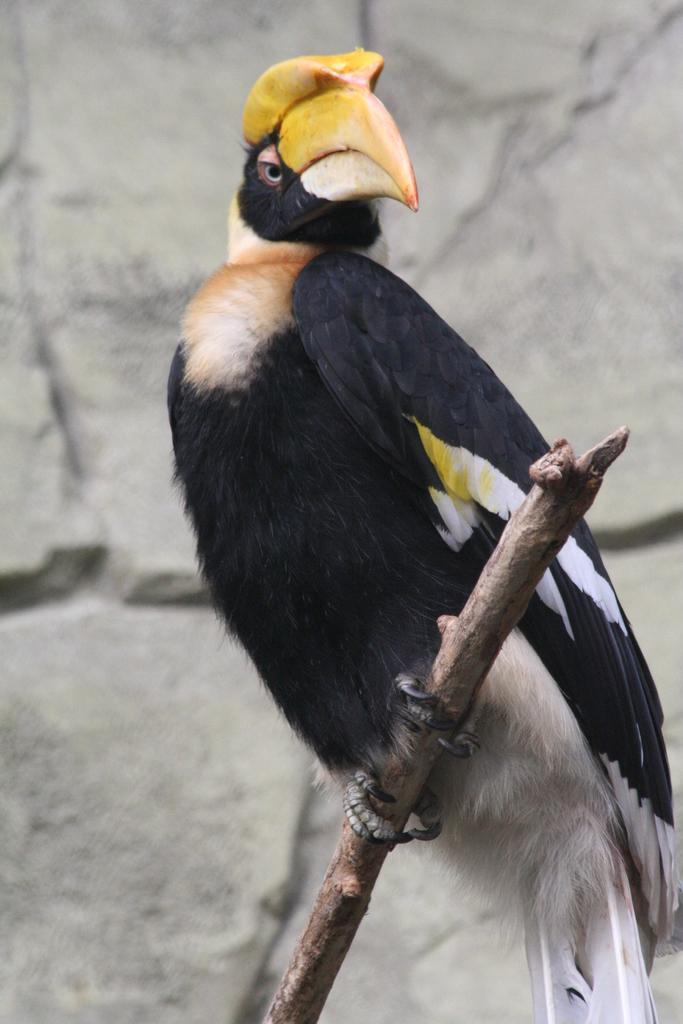What type of animal can be seen in the image? There is a bird in the image. Where is the bird located? The bird is sitting on a wooden object. What can be seen in the background of the image? There is a rock wall in the image. What type of wave can be seen crashing against the rock wall in the image? There is no wave present in the image; it features a bird sitting on a wooden object and a rock wall in the background. 